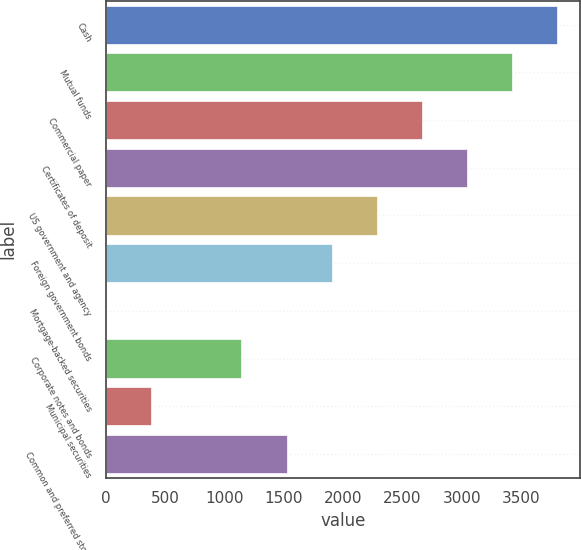<chart> <loc_0><loc_0><loc_500><loc_500><bar_chart><fcel>Cash<fcel>Mutual funds<fcel>Commercial paper<fcel>Certificates of deposit<fcel>US government and agency<fcel>Foreign government bonds<fcel>Mortgage-backed securities<fcel>Corporate notes and bonds<fcel>Municipal securities<fcel>Common and preferred stock<nl><fcel>3804<fcel>3423.72<fcel>2663.16<fcel>3043.44<fcel>2282.88<fcel>1902.6<fcel>1.2<fcel>1142.04<fcel>381.48<fcel>1522.32<nl></chart> 